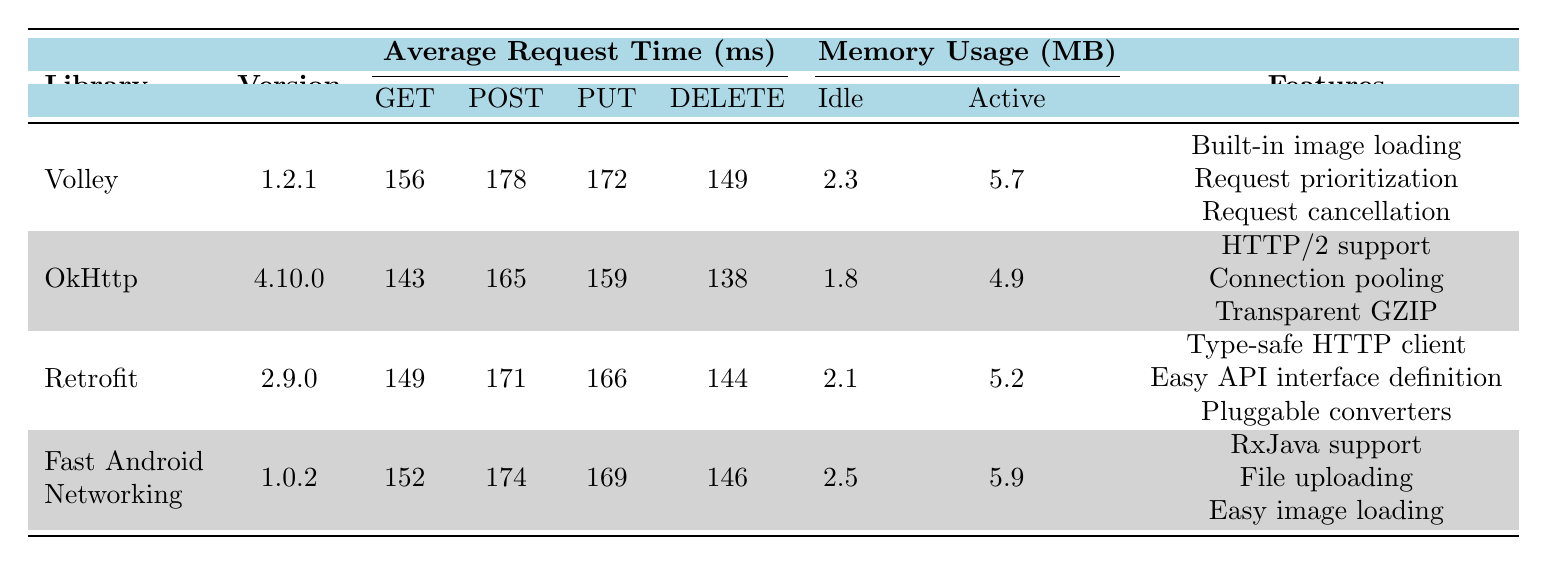What is the average request time for GET requests in OkHttp? The table shows the average request time for GET requests under the OkHttp library, which is listed as 143 ms.
Answer: 143 ms Which library has the highest memory usage when active? By comparing the active memory usage values from the table, Fast Android Networking has the highest value at 5.9 MB.
Answer: Fast Android Networking What is the average memory usage (in MB) for all libraries when idle? To find the average idle memory usage, we add the idle usage values: 2.3 (Volley) + 1.8 (OkHttp) + 2.1 (Retrofit) + 2.5 (Fast Android Networking) = 8.7 MB. Then divide by the number of libraries (4): 8.7 / 4 = 2.175 MB.
Answer: 2.175 MB Which library has the lowest CPU usage when active? The table shows that OkHttp has the lowest active CPU usage at 2.8%.
Answer: OkHttp Is it true that Retrofit has the fastest average request time for POST requests compared to other libraries? Checking the average POST request times, Retrofit is at 171 ms, whereas Volley is at 178 ms, Fast Android Networking at 174 ms, and OkHttp at 165 ms. Therefore, Retrofit does not have the fastest; OkHttp has the fastest POST time.
Answer: No What is the difference in average request time for DELETE requests between Volley and Fast Android Networking? The DELETE request time for Volley is 149 ms and for Fast Android Networking it is 146 ms. The difference is 149 - 146 = 3 ms.
Answer: 3 ms Which library features HTTP/2 support? The table lists OkHttp as having HTTP/2 support as one of its features.
Answer: OkHttp Total average request time of GET requests across all libraries? Summing the GET times: 156 (Volley) + 143 (OkHttp) + 149 (Retrofit) + 152 (Fast Android Networking) = 600 ms. Then, divide by the number of libraries (4): 600 / 4 = 150 ms.
Answer: 150 ms Which library has the highest average request time for PUT requests? By comparing the PUT request times, Volley has an average time of 172 ms, which is higher than 159 ms (OkHttp), 166 ms (Retrofit), and 169 ms (Fast Android Networking).
Answer: Volley How does the memory usage of Volley in idle state compare to that of Retrofit? Volley has an idle memory usage of 2.3 MB and Retrofit has 2.1 MB. Thus, Volley uses 0.2 MB more than Retrofit when idle.
Answer: 0.2 MB more What is the highest average request time (ms) among all DELETE requests? Looking at the DELETE request times, the highest is 149 ms for Volley, compared to 138 ms for OkHttp, 144 ms for Retrofit, and 146 ms for Fast Android Networking.
Answer: 149 ms 